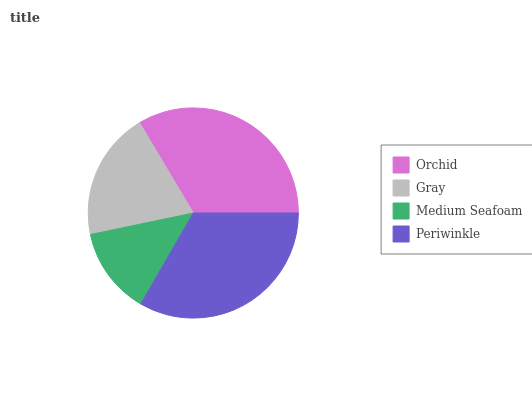Is Medium Seafoam the minimum?
Answer yes or no. Yes. Is Orchid the maximum?
Answer yes or no. Yes. Is Gray the minimum?
Answer yes or no. No. Is Gray the maximum?
Answer yes or no. No. Is Orchid greater than Gray?
Answer yes or no. Yes. Is Gray less than Orchid?
Answer yes or no. Yes. Is Gray greater than Orchid?
Answer yes or no. No. Is Orchid less than Gray?
Answer yes or no. No. Is Periwinkle the high median?
Answer yes or no. Yes. Is Gray the low median?
Answer yes or no. Yes. Is Medium Seafoam the high median?
Answer yes or no. No. Is Medium Seafoam the low median?
Answer yes or no. No. 